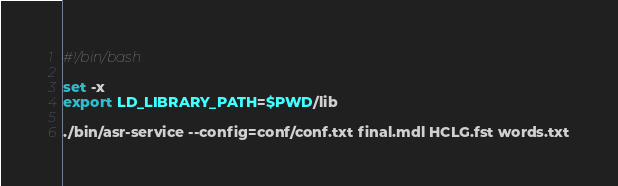Convert code to text. <code><loc_0><loc_0><loc_500><loc_500><_Bash_>#!/bin/bash

set -x 
export LD_LIBRARY_PATH=$PWD/lib

./bin/asr-service --config=conf/conf.txt final.mdl HCLG.fst words.txt
</code> 